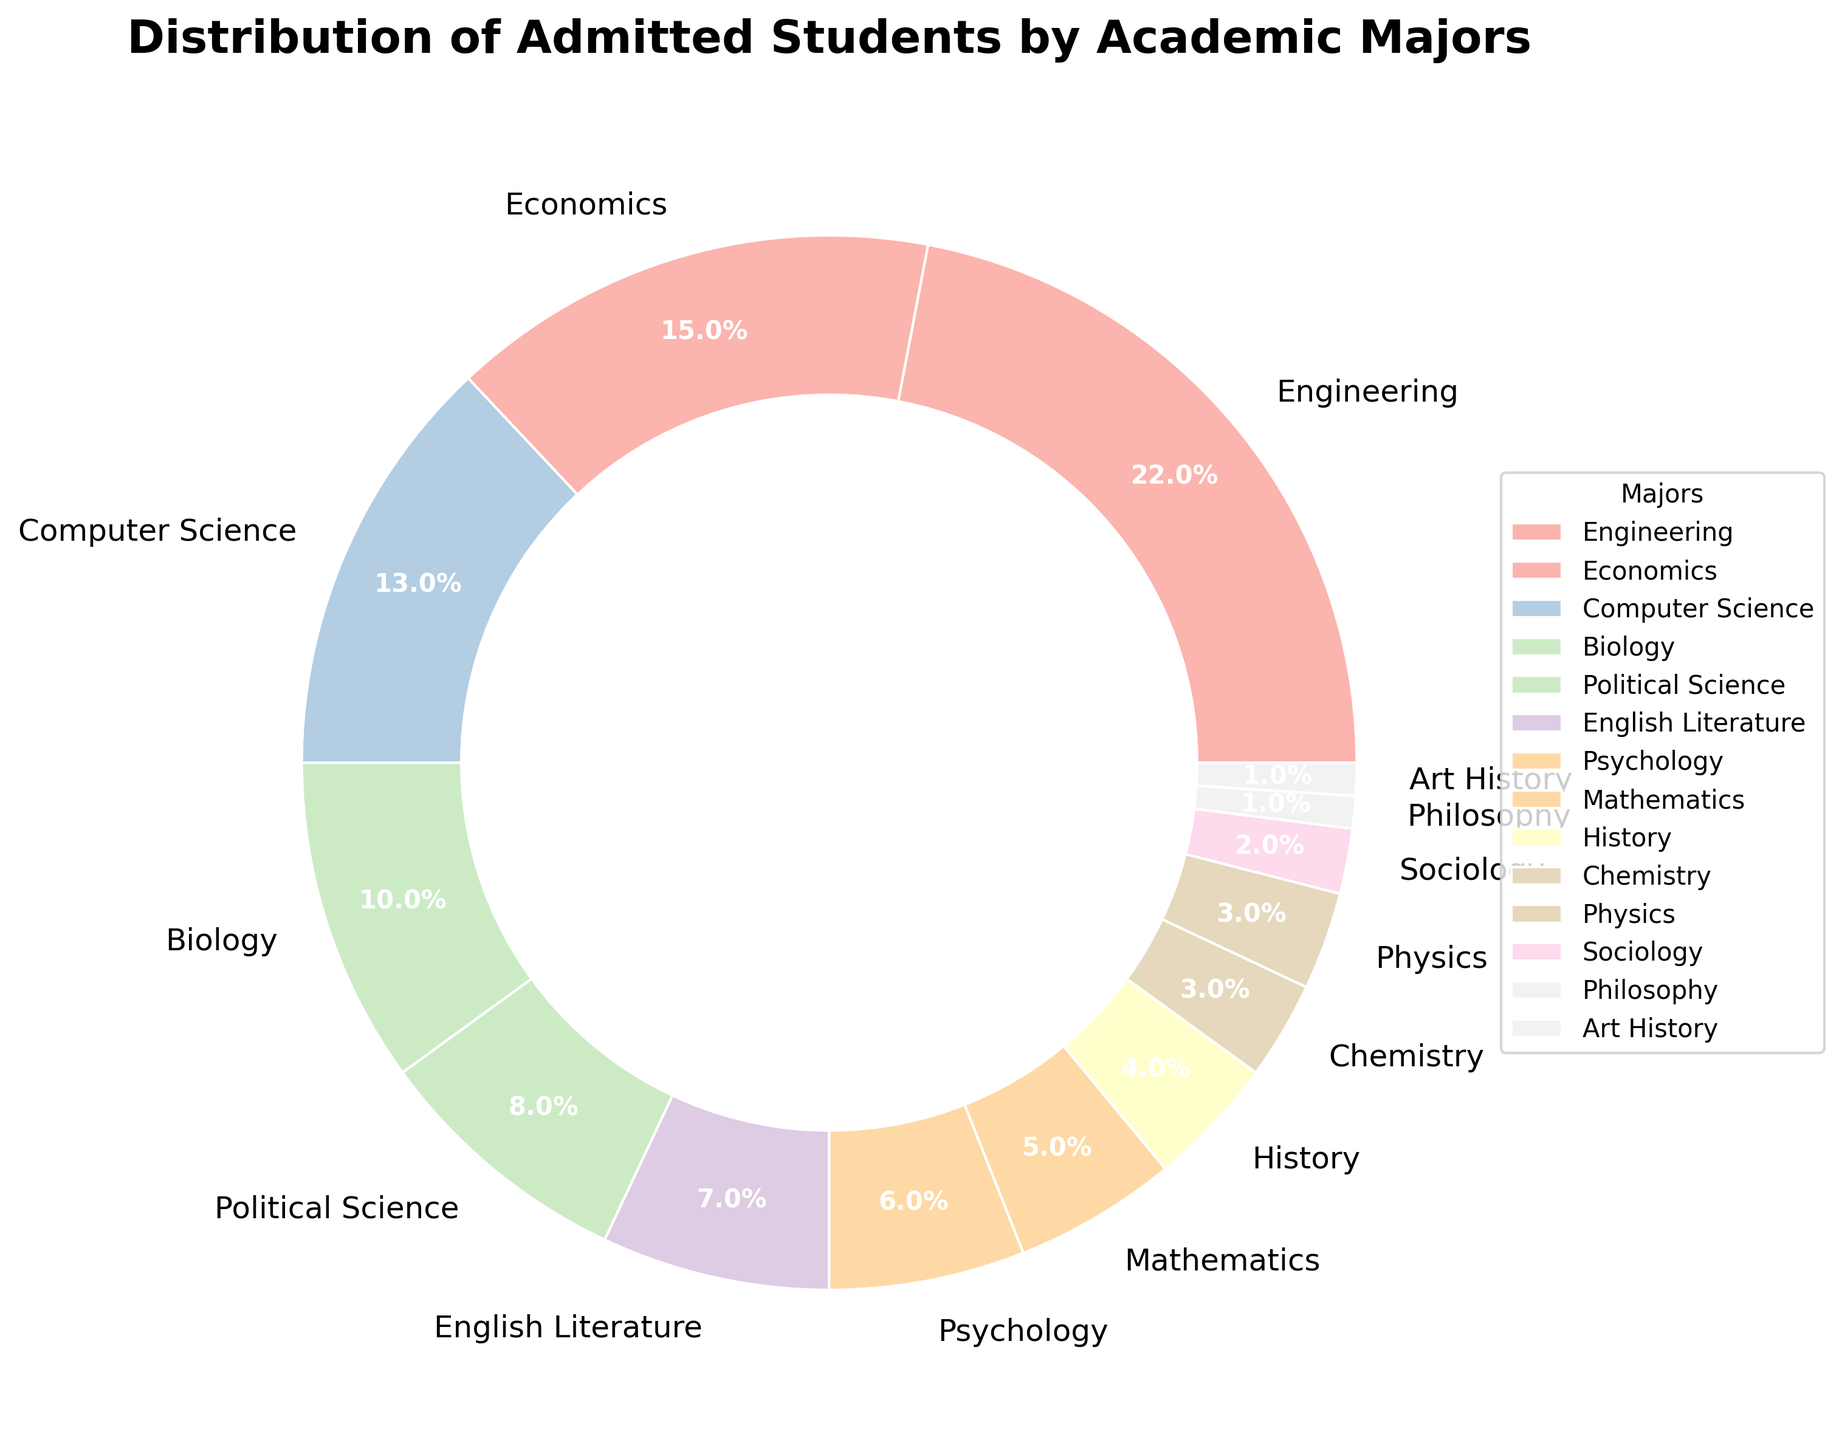What percentage of admitted students are majoring in Engineering or Economics combined? To find the combined percentage of admitted students majoring in Engineering and Economics, add their individual percentages: 22% (Engineering) + 15% (Economics).
Answer: 37% Which academic major has the smallest representation among admitted students? To find the least represented major, look for the smallest percentage. Both Philosophy and Art History are represented by 1%.
Answer: Philosophy and Art History Is the percentage of admitted students majoring in Biology higher or lower than those majoring in Political Science? Compare the percentages: Biology has 10% and Political Science has 8%. Since 10% > 8%, Biology is higher.
Answer: Higher What is the difference in the percentage of admitted students between Computer Science and Psychology? Subtract the percentage of Psychology from Computer Science: 13% (Computer Science) - 6% (Psychology).
Answer: 7% How does the number of students majoring in Chemistry compare to those majoring in Physics? Compare the percentages of Chemistry (3%) and Physics (3%). Since both have the same percentage, they are equal.
Answer: Equal What is the total percentage of admitted students in Biology, Chemistry, and Physics combined? Add the percentages for Biology, Chemistry, and Physics: 10% (Biology) + 3% (Chemistry) + 3% (Physics).
Answer: 16% Which major has a higher percentage of admitted students, Psychology or Mathematics? Compare the percentages: Psychology (6%) and Mathematics (5%). Since 6% > 5%, Psychology is higher.
Answer: Psychology What is the combined percentage of students majoring in English Literature and Sociology? Add the percentages for English Literature and Sociology: 7% (English Literature) + 2% (Sociology).
Answer: 9% Which fields have the exact same percentage of admitted students, and what is that percentage? Both Chemistry and Physics have the same percentage of admitted students, each with 3%.
Answer: Chemistry and Physics How many majors have a percentage of 5% or more? Count the majors with percentages 5% or more: Engineering, Economics, Computer Science, Biology, Political Science, English Literature, and Psychology. This results in 7 majors.
Answer: 7 